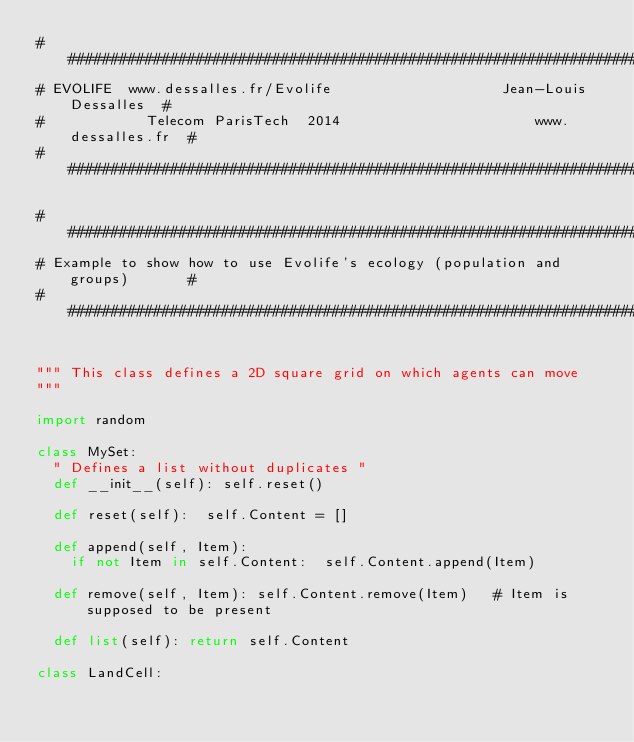Convert code to text. <code><loc_0><loc_0><loc_500><loc_500><_Python_>##############################################################################
# EVOLIFE  www.dessalles.fr/Evolife                    Jean-Louis Dessalles  #
#            Telecom ParisTech  2014                       www.dessalles.fr  #
##############################################################################

##############################################################################
# Example to show how to use Evolife's ecology (population and groups)       #
##############################################################################


""" This class defines a 2D square grid on which agents can move
"""

import random
		
class MySet:
	" Defines a list without duplicates "
	def __init__(self): self.reset()

	def reset(self):	self.Content = []

	def append(self, Item):
		if not Item in self.Content:	self.Content.append(Item)

	def remove(self, Item): self.Content.remove(Item) 	# Item is supposed to be present		
	
	def list(self):	return self.Content

class LandCell:</code> 